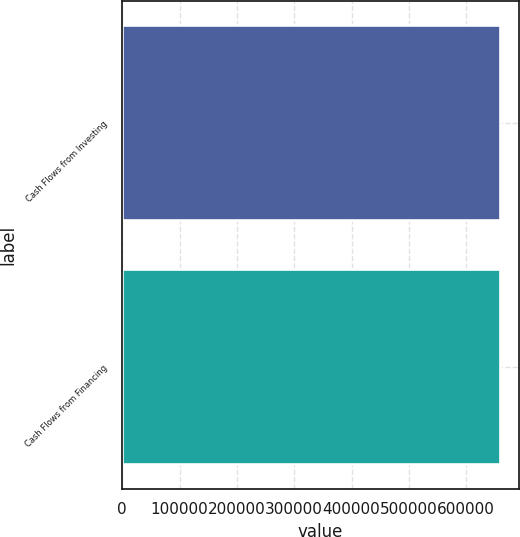Convert chart to OTSL. <chart><loc_0><loc_0><loc_500><loc_500><bar_chart><fcel>Cash Flows from Investing<fcel>Cash Flows from Financing<nl><fcel>659300<fcel>659300<nl></chart> 